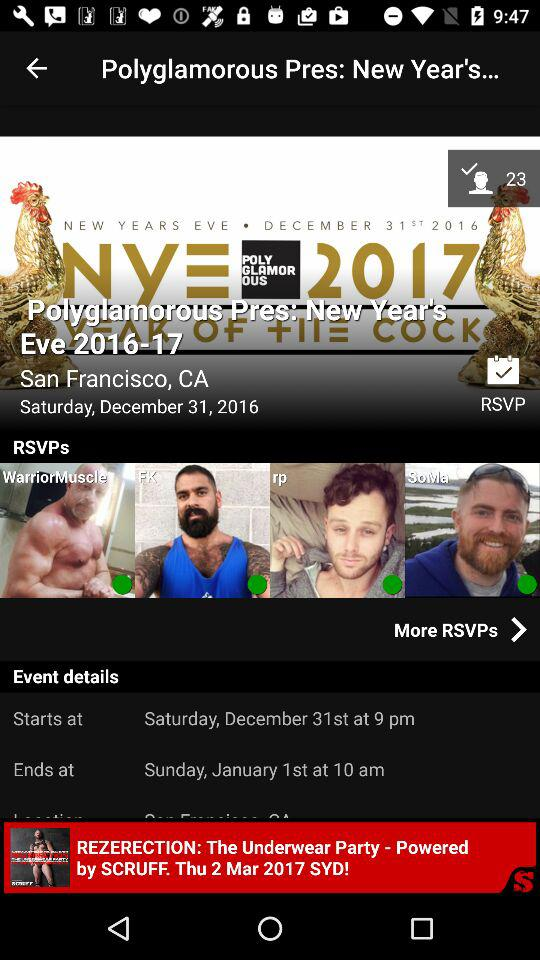What is the date of "REZERECTION: The Underwear Party"? The date is Thursday, March 2, 2017. 